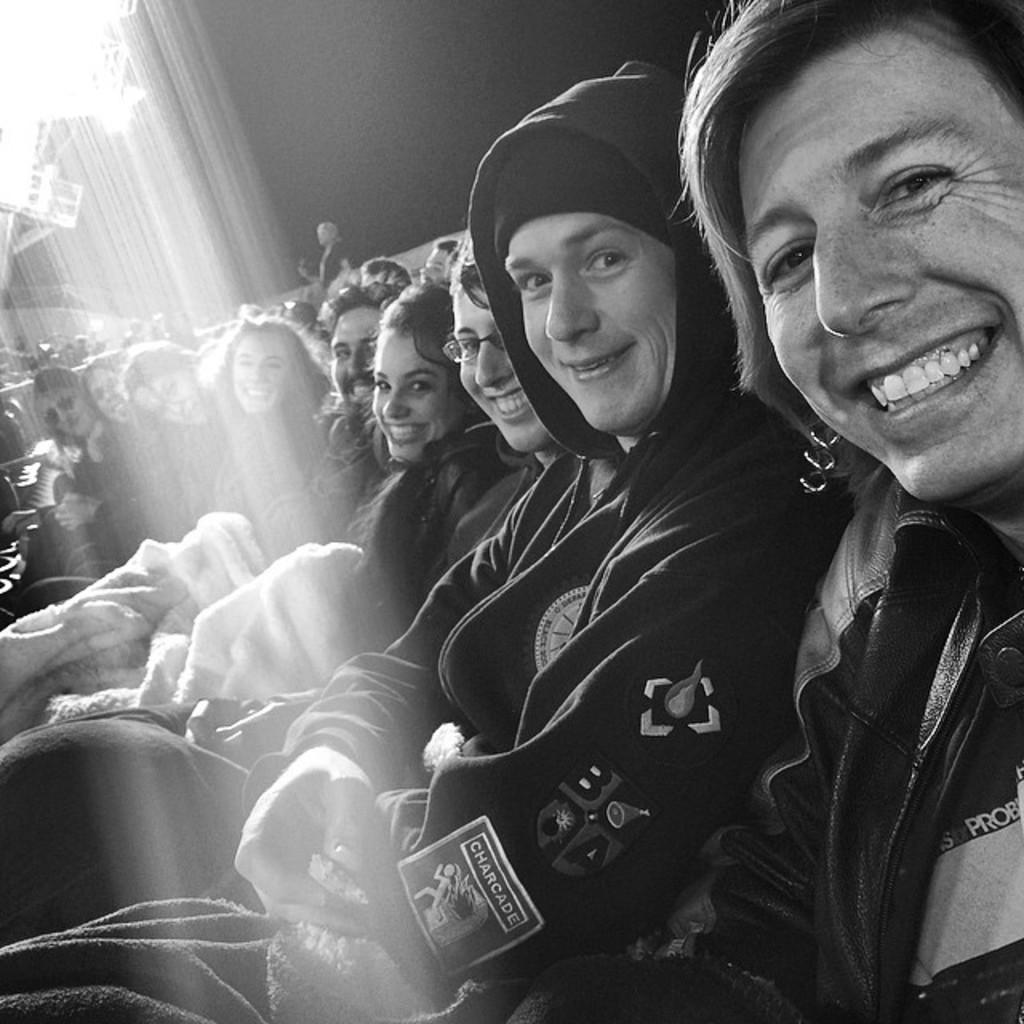Could you give a brief overview of what you see in this image? This is a black and white image. In this image we can see a group of people sitting. On the backside we can see a wall, lights and a person standing. 